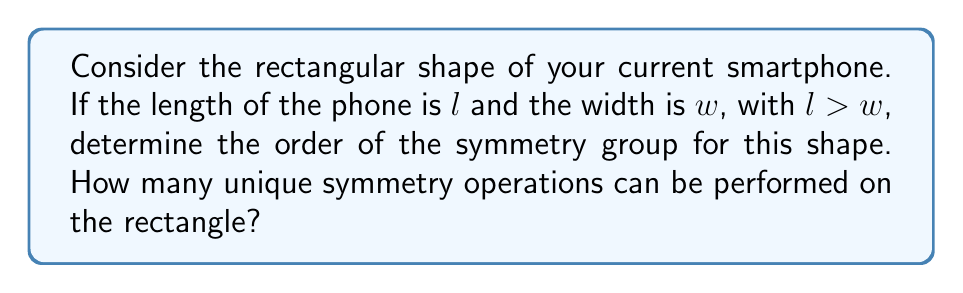Teach me how to tackle this problem. Let's approach this step-by-step:

1) First, we need to understand what symmetry operations are possible for a rectangle:

   a) Identity (E): Leaving the rectangle as it is.
   b) Rotation by 180° (C2): Rotating the rectangle by 180° around its center.
   c) Reflection across the vertical axis (Rv): Flipping the rectangle left to right.
   d) Reflection across the horizontal axis (Rh): Flipping the rectangle top to bottom.

2) These operations form a group under composition. Let's verify:

   - The identity element (E) exists.
   - Each operation has an inverse (in fact, each is its own inverse).
   - The operations are closed under composition.
   - The operations are associative.

3) To determine the order of the group, we count the number of unique operations:

   $$|G| = |\{E, C2, Rv, Rh\}| = 4$$

4) This group is isomorphic to the Klein four-group, $V_4$.

5) It's worth noting that if $l = w$ (i.e., if the rectangle were a square), we would have additional symmetries, but given that your current smartphone has $l > w$, we stick with the rectangular case.

[asy]
unitsize(1cm);
pair A = (0,0), B = (3,0), C = (3,2), D = (0,2);
draw(A--B--C--D--cycle);
label("$l$", (1.5,0), S);
label("$w$", (3,1), E);
draw((1.5,0)--(1.5,2), dashed);
draw((0,1)--(3,1), dashed);
[/asy]
Answer: The order of the symmetry group for the rectangular shape of the smartphone is 4. 